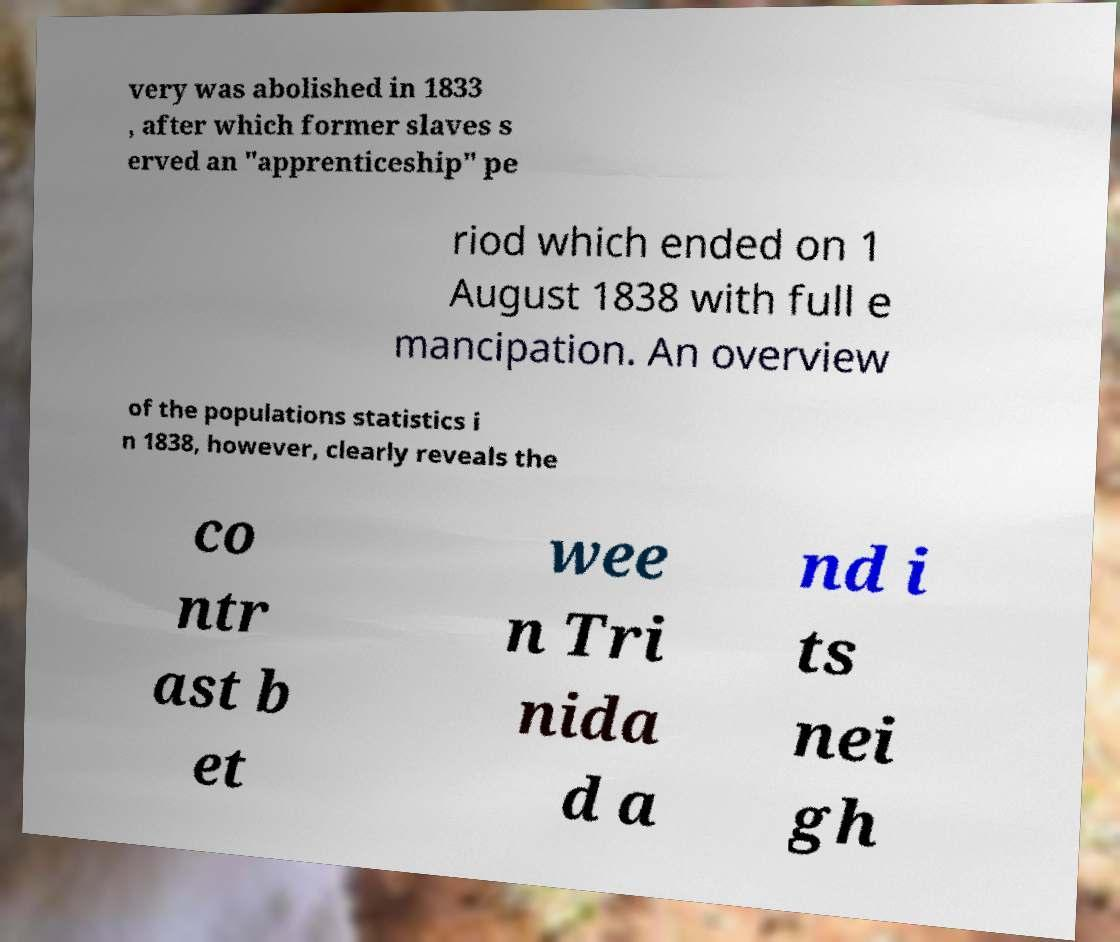Can you read and provide the text displayed in the image?This photo seems to have some interesting text. Can you extract and type it out for me? very was abolished in 1833 , after which former slaves s erved an "apprenticeship" pe riod which ended on 1 August 1838 with full e mancipation. An overview of the populations statistics i n 1838, however, clearly reveals the co ntr ast b et wee n Tri nida d a nd i ts nei gh 